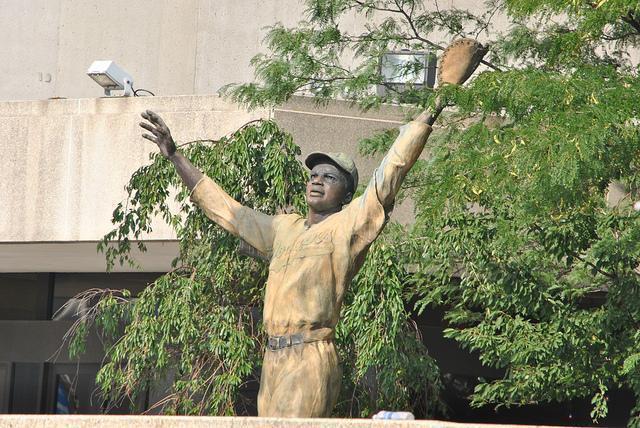What is the statue wearing?
Select the correct answer and articulate reasoning with the following format: 'Answer: answer
Rationale: rationale.'
Options: Tiara, gas mask, crown, belt. Answer: belt.
Rationale: The statue has a belt over the uniform. 